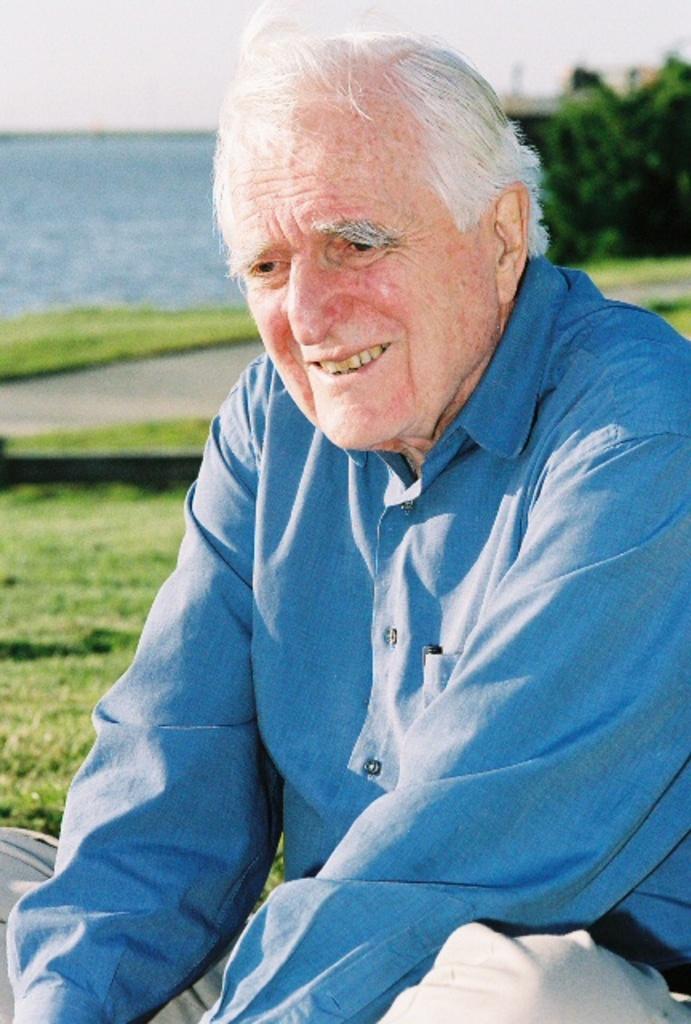Describe this image in one or two sentences. In the image we can see there is a man sitting on the ground, the ground is covered with grass and behind there is water. 